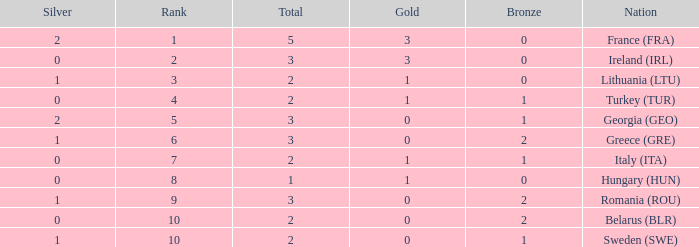What's the total of Sweden (SWE) having less than 1 silver? None. 